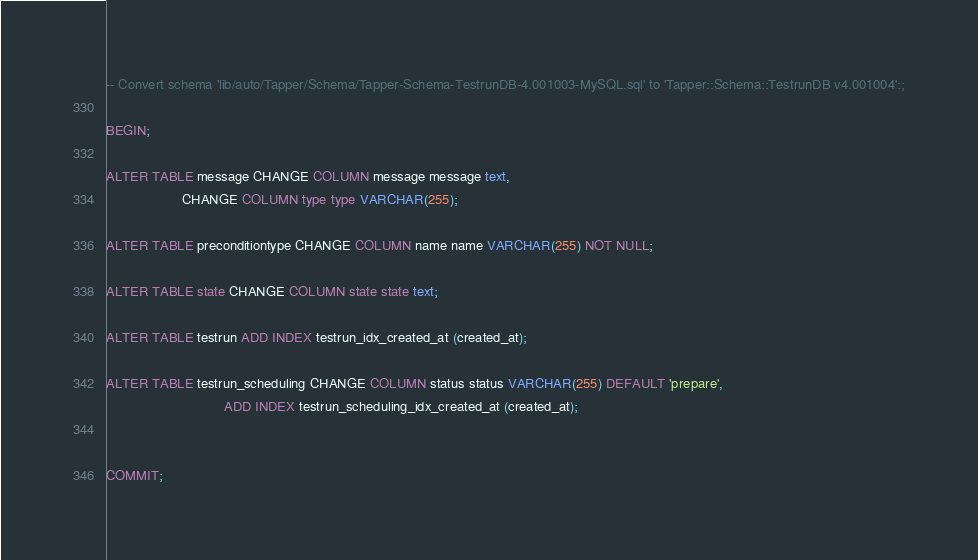Convert code to text. <code><loc_0><loc_0><loc_500><loc_500><_SQL_>-- Convert schema 'lib/auto/Tapper/Schema/Tapper-Schema-TestrunDB-4.001003-MySQL.sql' to 'Tapper::Schema::TestrunDB v4.001004':;

BEGIN;

ALTER TABLE message CHANGE COLUMN message message text,
                    CHANGE COLUMN type type VARCHAR(255);

ALTER TABLE preconditiontype CHANGE COLUMN name name VARCHAR(255) NOT NULL;

ALTER TABLE state CHANGE COLUMN state state text;

ALTER TABLE testrun ADD INDEX testrun_idx_created_at (created_at);

ALTER TABLE testrun_scheduling CHANGE COLUMN status status VARCHAR(255) DEFAULT 'prepare',
                               ADD INDEX testrun_scheduling_idx_created_at (created_at);


COMMIT;

</code> 